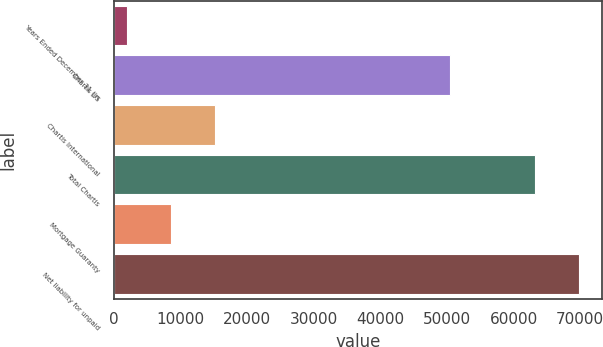Convert chart. <chart><loc_0><loc_0><loc_500><loc_500><bar_chart><fcel>Years Ended December 31 (in<fcel>Chartis US<fcel>Chartis International<fcel>Total Chartis<fcel>Mortgage Guaranty<fcel>Net liability for unpaid<nl><fcel>2009<fcel>50498<fcel>15187<fcel>63186<fcel>8598<fcel>69775<nl></chart> 